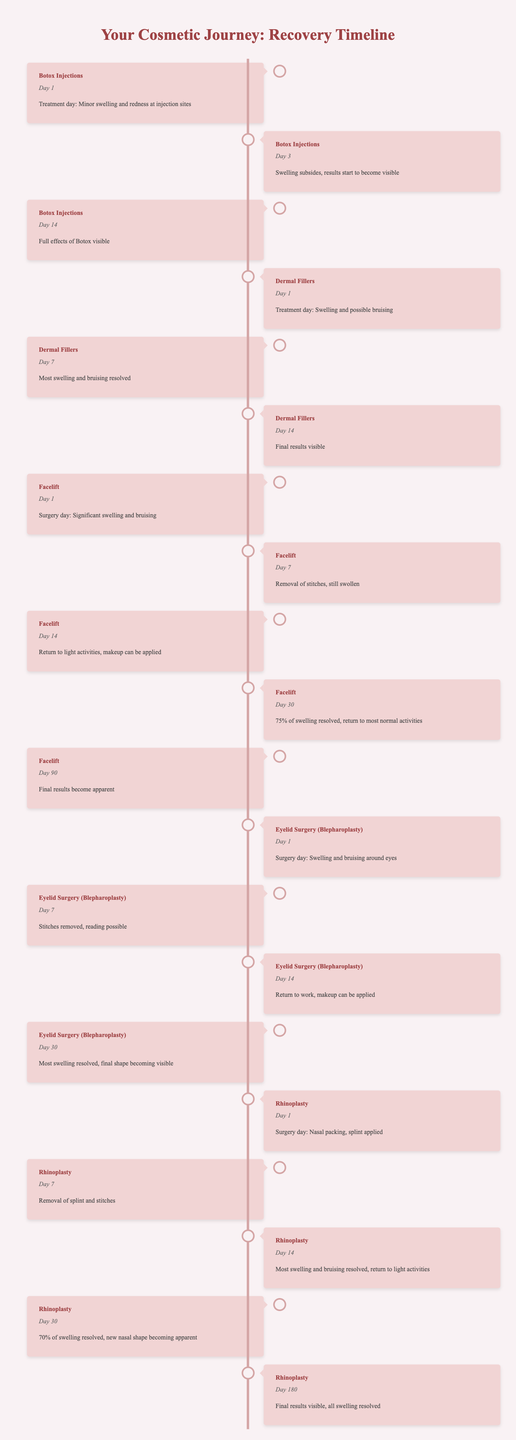What happens on Day 1 of a Facelift? According to the table, the event on Day 1 for a Facelift is "Surgery day: Significant swelling and bruising." This indicates that the initial effects of the procedure are noticeable right after surgery.
Answer: Significant swelling and bruising How many days until the full effects of Botox are visible? From the timeline, Botox's full effects are visible on Day 14. Since the treatment day is Day 1, it takes 13 days (Day 14 minus Day 1) for the full effects to appear.
Answer: 13 days Is it true that most swelling from Dermal Fillers is resolved by Day 7? The table shows that on Day 7 for Dermal Fillers, "Most swelling and bruising resolved," confirming that it is indeed true that most swelling resolves by this time.
Answer: Yes What percentage of swelling is resolved 30 days after a Facelift? By Day 30 after a Facelift, the event states that "75% of swelling resolved." This means a significant portion of the swelling has decreased by this time.
Answer: 75% Which procedure has the longest recovery timeline before final results are visible? From the data, Rhinoplasty has its final results visible at Day 180, while the other procedures have earlier timelines for final results. Therefore, it has the longest recovery timeline for visible results.
Answer: Rhinoplasty What is the average time for the final results to be visible across all procedures listed? The final result days for each procedure are 14 (Botox), 14 (Dermal Fillers), 90 (Facelift), 30 (Eyelid Surgery), and 180 (Rhinoplasty). To find the average: (14 + 14 + 90 + 30 + 180) / 5 = 66. The average time for final results to show is therefore 66 days.
Answer: 66 days On what day can makeup be applied after an Eyelid Surgery? According to the timeline, makeup can be applied again on Day 14 after the Eyelid Surgery, which is when the recovery process allows it.
Answer: Day 14 Are the results of Botox visible sooner than those of Dermal Fillers? Yes, Botox's full effects are visible by Day 14, while Dermal Fillers show final results also by Day 14, but the effects of Botox begin showing at Day 3, indicating a quicker visible change overall.
Answer: Yes What happens 30 days after a Rhinoplasty? The event listed for Day 30 after Rhinoplasty states, "70% of swelling resolved, new nasal shape becoming apparent," indicating recovery progress at this point.
Answer: 70% of swelling resolved, new shape apparent 